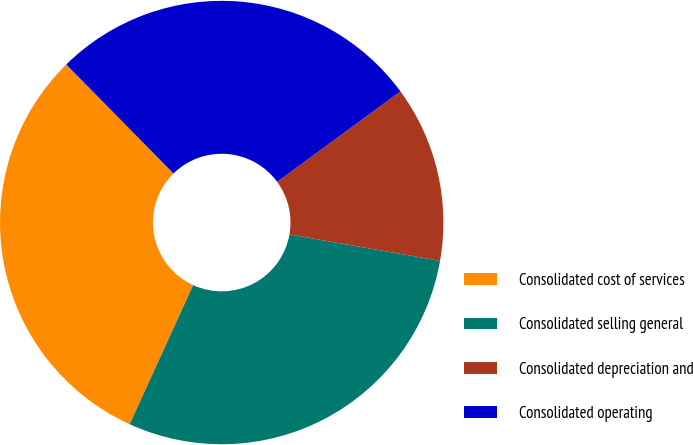Convert chart. <chart><loc_0><loc_0><loc_500><loc_500><pie_chart><fcel>Consolidated cost of services<fcel>Consolidated selling general<fcel>Consolidated depreciation and<fcel>Consolidated operating<nl><fcel>30.82%<fcel>29.05%<fcel>12.84%<fcel>27.29%<nl></chart> 